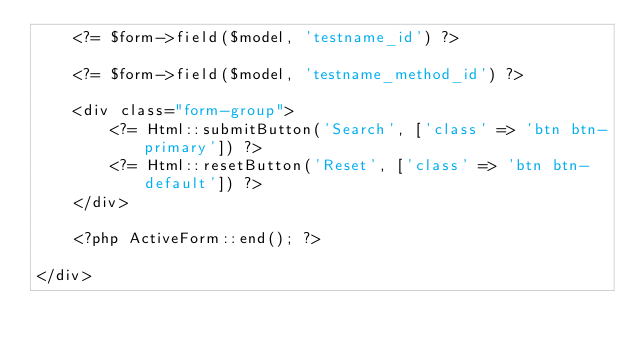<code> <loc_0><loc_0><loc_500><loc_500><_PHP_>    <?= $form->field($model, 'testname_id') ?>

    <?= $form->field($model, 'testname_method_id') ?>

    <div class="form-group">
        <?= Html::submitButton('Search', ['class' => 'btn btn-primary']) ?>
        <?= Html::resetButton('Reset', ['class' => 'btn btn-default']) ?>
    </div>

    <?php ActiveForm::end(); ?>

</div>
</code> 